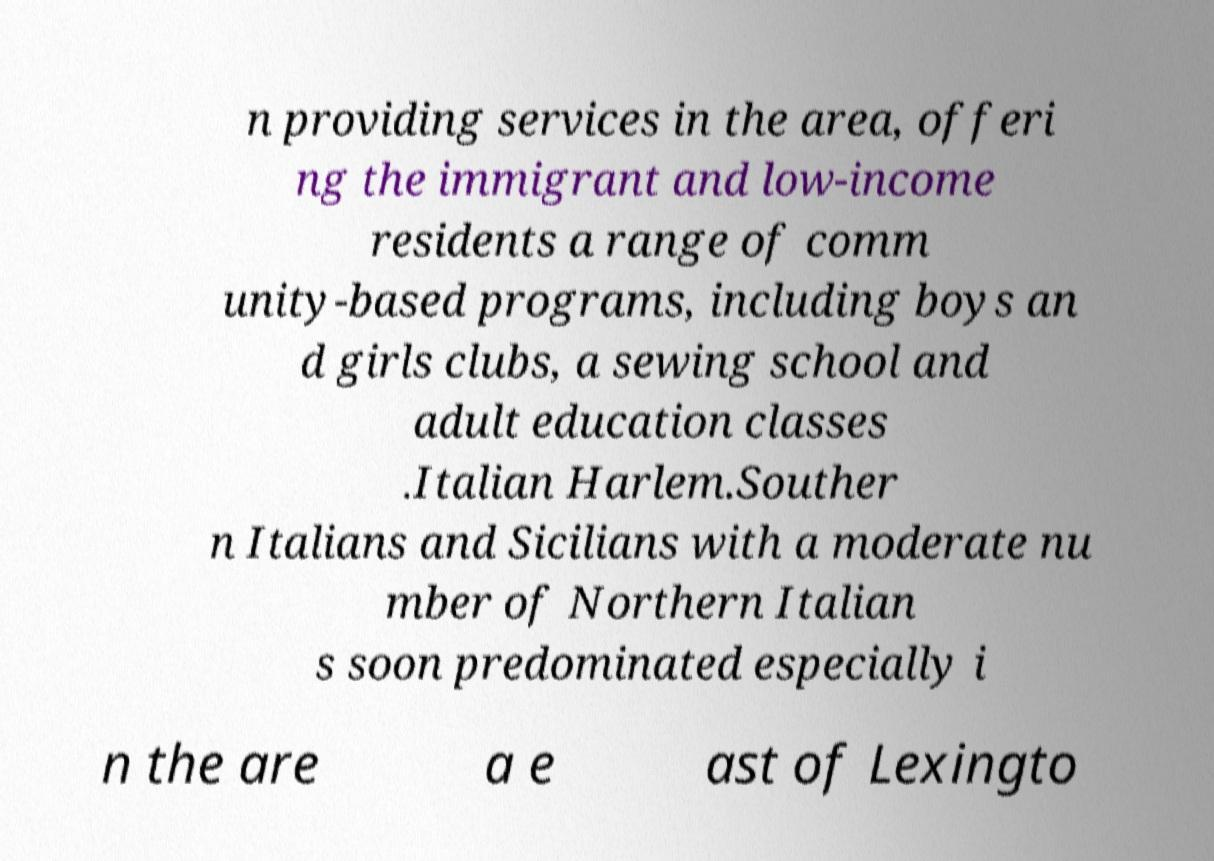Could you extract and type out the text from this image? n providing services in the area, offeri ng the immigrant and low-income residents a range of comm unity-based programs, including boys an d girls clubs, a sewing school and adult education classes .Italian Harlem.Souther n Italians and Sicilians with a moderate nu mber of Northern Italian s soon predominated especially i n the are a e ast of Lexingto 